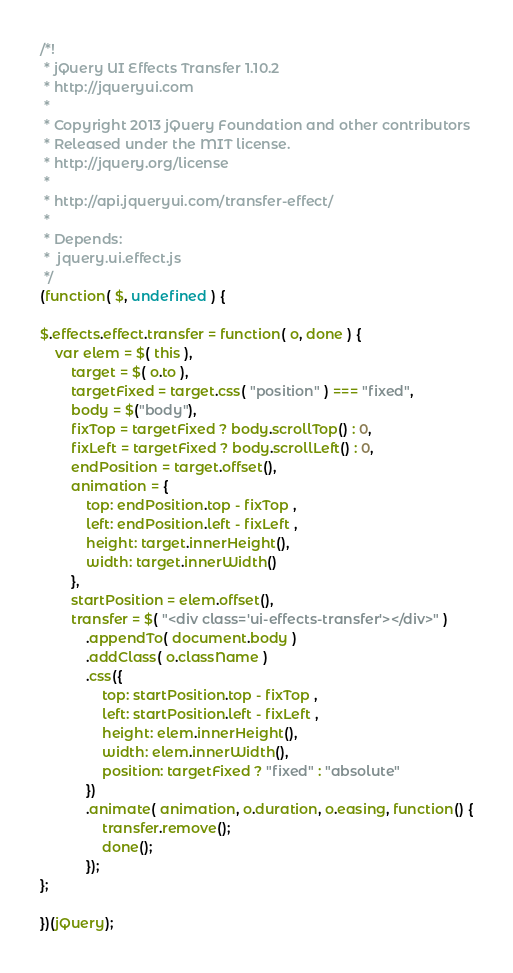Convert code to text. <code><loc_0><loc_0><loc_500><loc_500><_JavaScript_>/*!
 * jQuery UI Effects Transfer 1.10.2
 * http://jqueryui.com
 *
 * Copyright 2013 jQuery Foundation and other contributors
 * Released under the MIT license.
 * http://jquery.org/license
 *
 * http://api.jqueryui.com/transfer-effect/
 *
 * Depends:
 *	jquery.ui.effect.js
 */
(function( $, undefined ) {

$.effects.effect.transfer = function( o, done ) {
	var elem = $( this ),
		target = $( o.to ),
		targetFixed = target.css( "position" ) === "fixed",
		body = $("body"),
		fixTop = targetFixed ? body.scrollTop() : 0,
		fixLeft = targetFixed ? body.scrollLeft() : 0,
		endPosition = target.offset(),
		animation = {
			top: endPosition.top - fixTop ,
			left: endPosition.left - fixLeft ,
			height: target.innerHeight(),
			width: target.innerWidth()
		},
		startPosition = elem.offset(),
		transfer = $( "<div class='ui-effects-transfer'></div>" )
			.appendTo( document.body )
			.addClass( o.className )
			.css({
				top: startPosition.top - fixTop ,
				left: startPosition.left - fixLeft ,
				height: elem.innerHeight(),
				width: elem.innerWidth(),
				position: targetFixed ? "fixed" : "absolute"
			})
			.animate( animation, o.duration, o.easing, function() {
				transfer.remove();
				done();
			});
};

})(jQuery);
</code> 